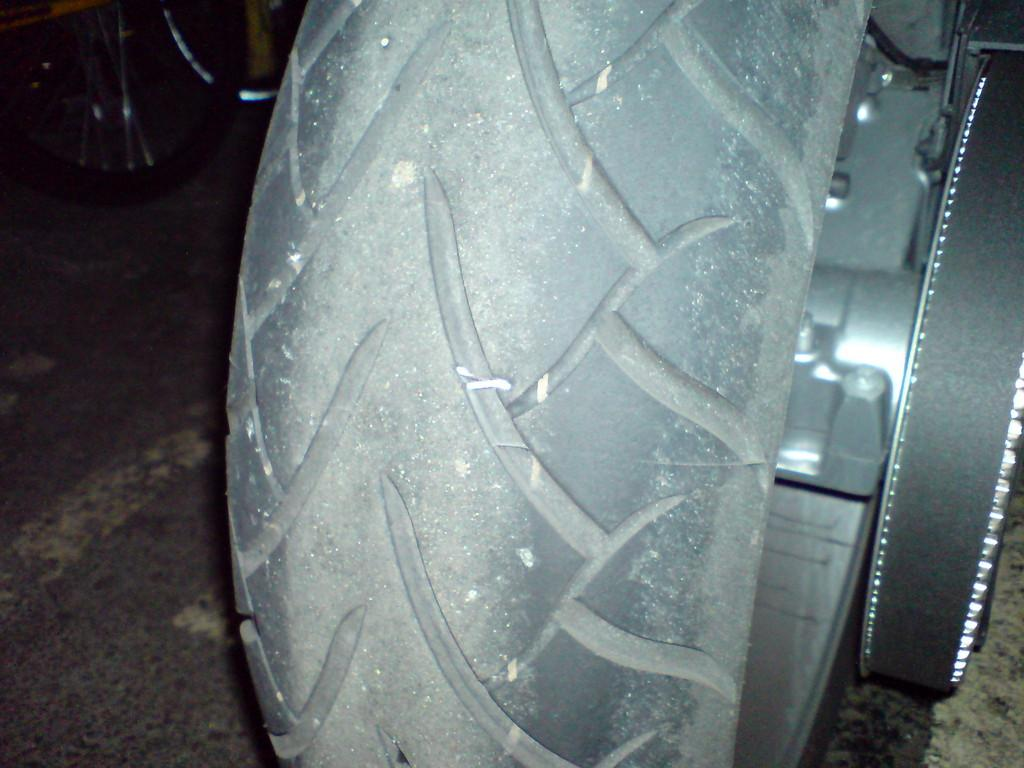What object is the main subject of the image? There is a vehicle tyre in the image. Can you describe the color of the tyre? The tyre is in ash color. What can be seen in the background of the image? The background of the image is black. How many bees are sitting on the table in the image? There are no bees or tables present in the image; it only features a vehicle tyre with a black background. 